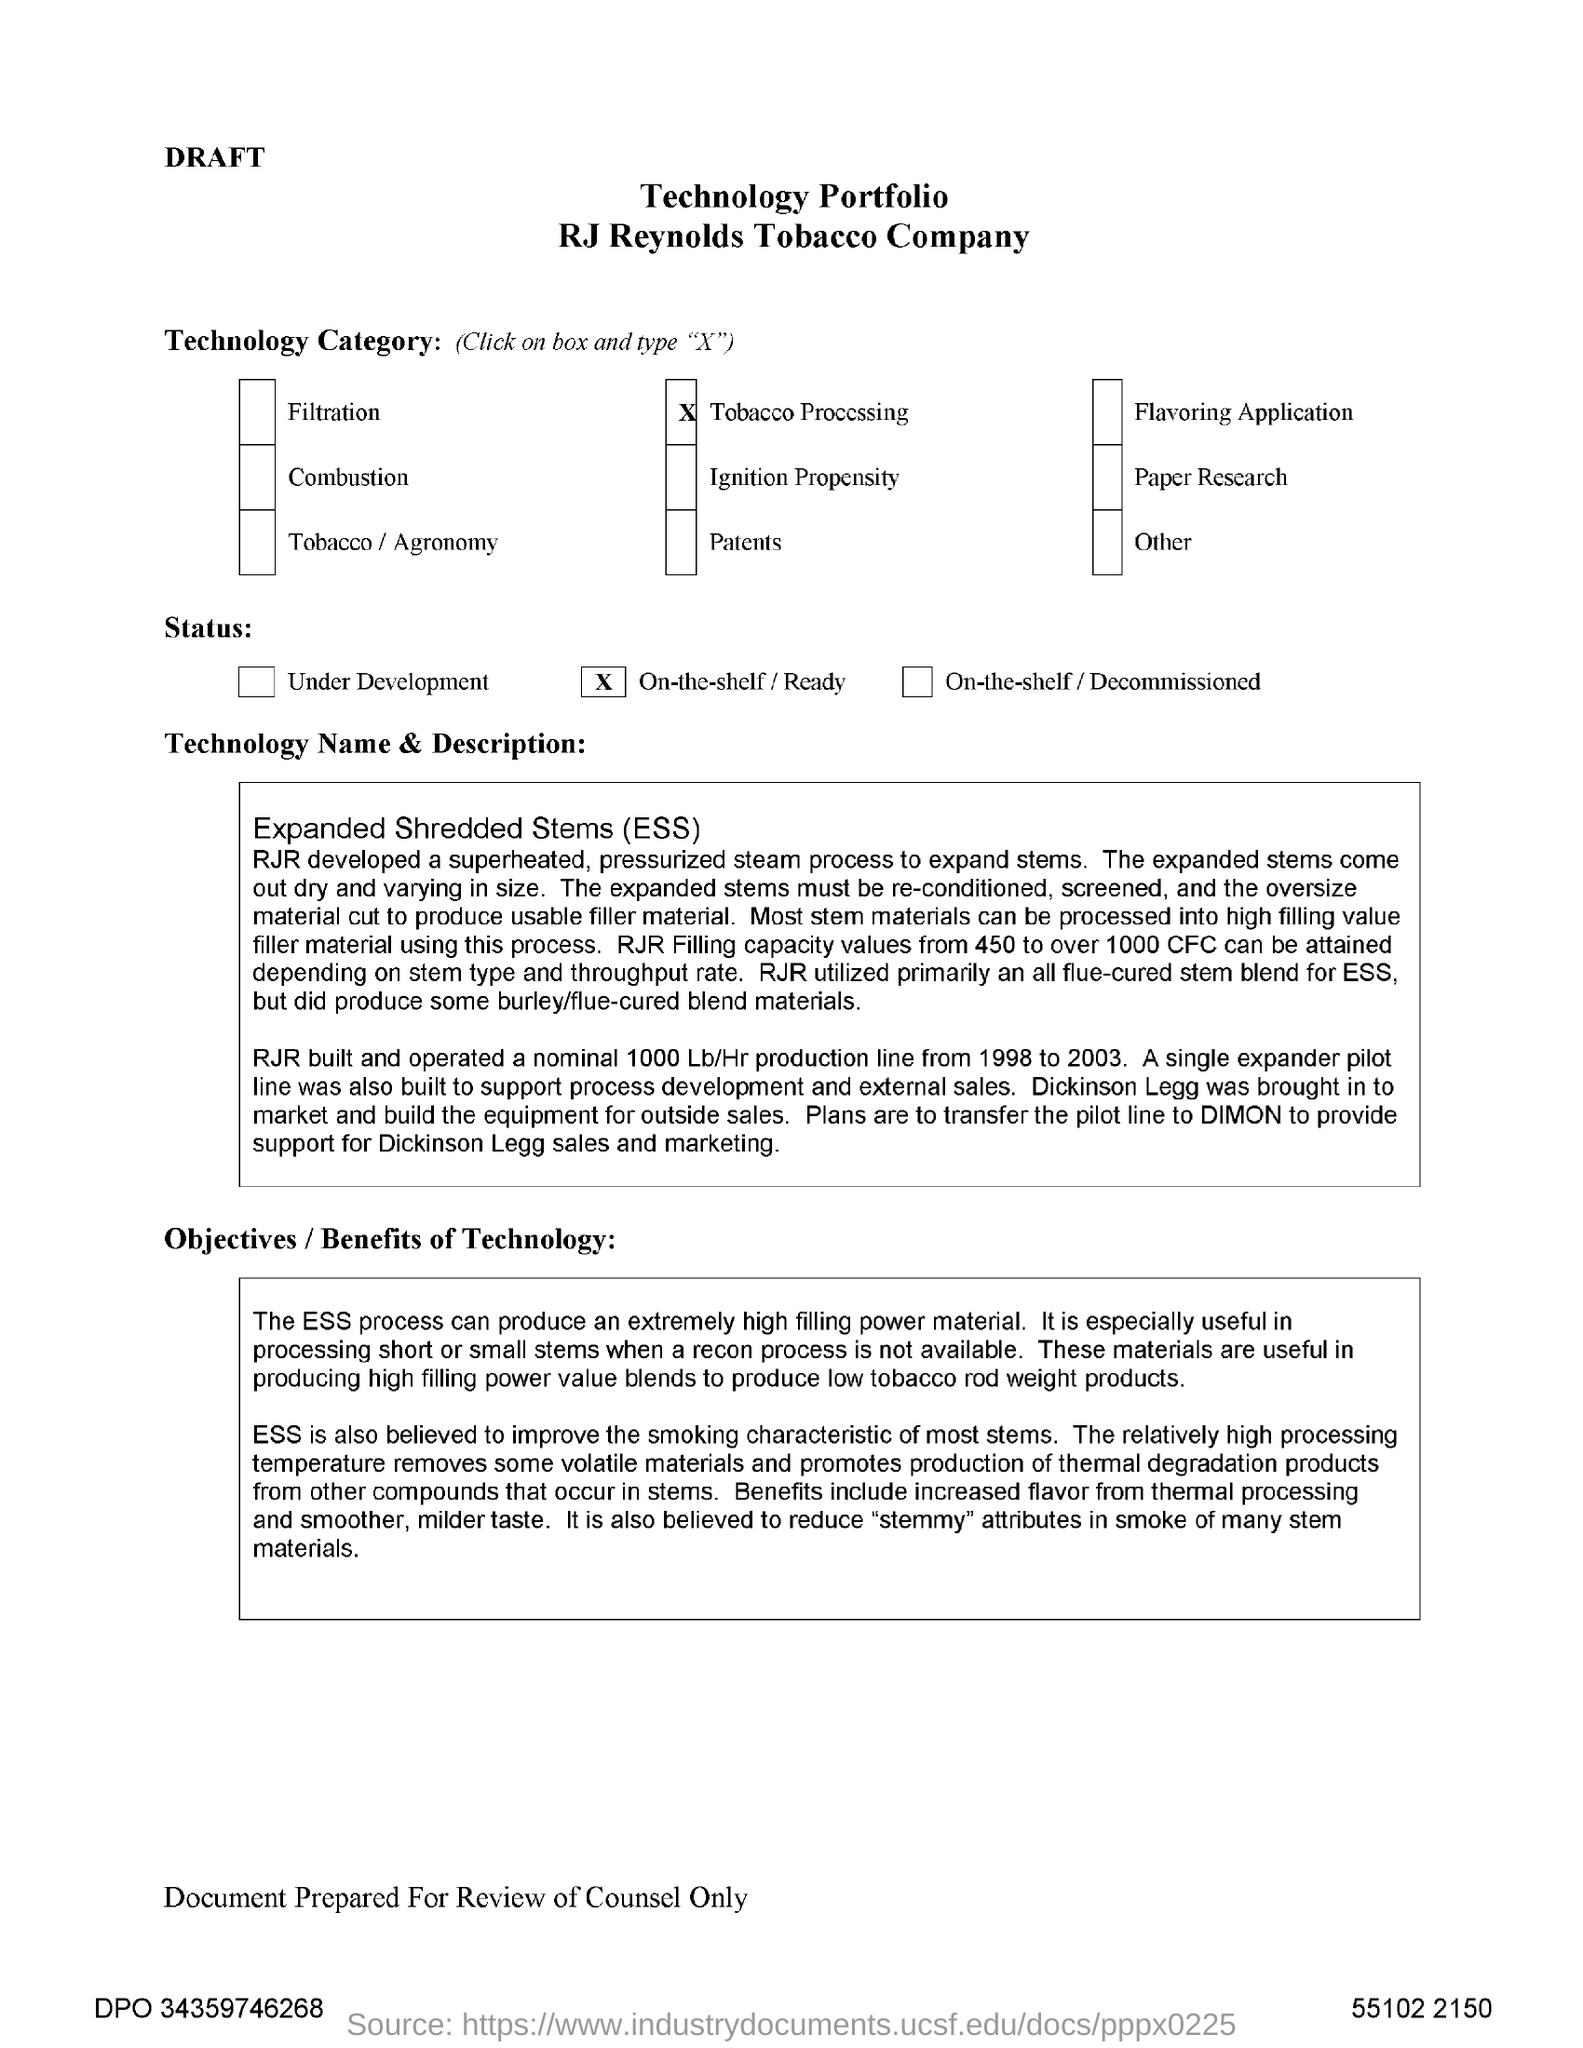What is the full form of ess?
Your answer should be very brief. Expanded Shredded Stems. What is the technology category selected?
Provide a short and direct response. Tobacco Processing. What is the range of RJR Filling capacity that can be attained in ESS process depending on stem type and throughput rate?
Make the answer very short. 450 to over 1000 CFC. What is the Status selected in the document?
Offer a very short reply. On-the-shelf / Ready. 